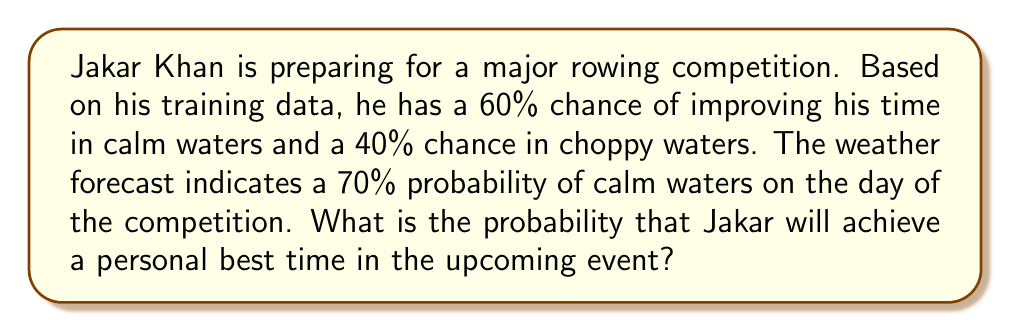Give your solution to this math problem. Let's approach this step-by-step using the law of total probability:

1) Define events:
   A: Jakar achieves a personal best time
   C: Calm waters
   Ch: Choppy waters

2) Given probabilities:
   P(C) = 0.70 (probability of calm waters)
   P(Ch) = 1 - P(C) = 0.30 (probability of choppy waters)
   P(A|C) = 0.60 (probability of achieving personal best in calm waters)
   P(A|Ch) = 0.40 (probability of achieving personal best in choppy waters)

3) Apply the law of total probability:
   $$P(A) = P(A|C) \cdot P(C) + P(A|Ch) \cdot P(Ch)$$

4) Substitute the values:
   $$P(A) = 0.60 \cdot 0.70 + 0.40 \cdot 0.30$$

5) Calculate:
   $$P(A) = 0.42 + 0.12 = 0.54$$

Therefore, the probability that Jakar will achieve a personal best time is 0.54 or 54%.
Answer: 0.54 